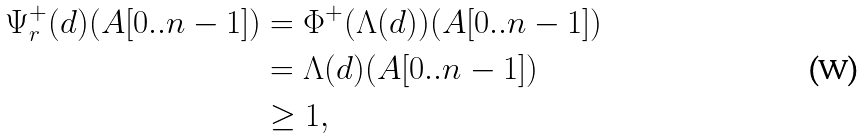<formula> <loc_0><loc_0><loc_500><loc_500>\Psi ^ { + } _ { r } ( d ) ( A [ 0 . . n - 1 ] ) & = \Phi ^ { + } ( \Lambda ( d ) ) ( A [ 0 . . n - 1 ] ) \\ & = \Lambda ( d ) ( A [ 0 . . n - 1 ] ) \\ & \geq 1 ,</formula> 